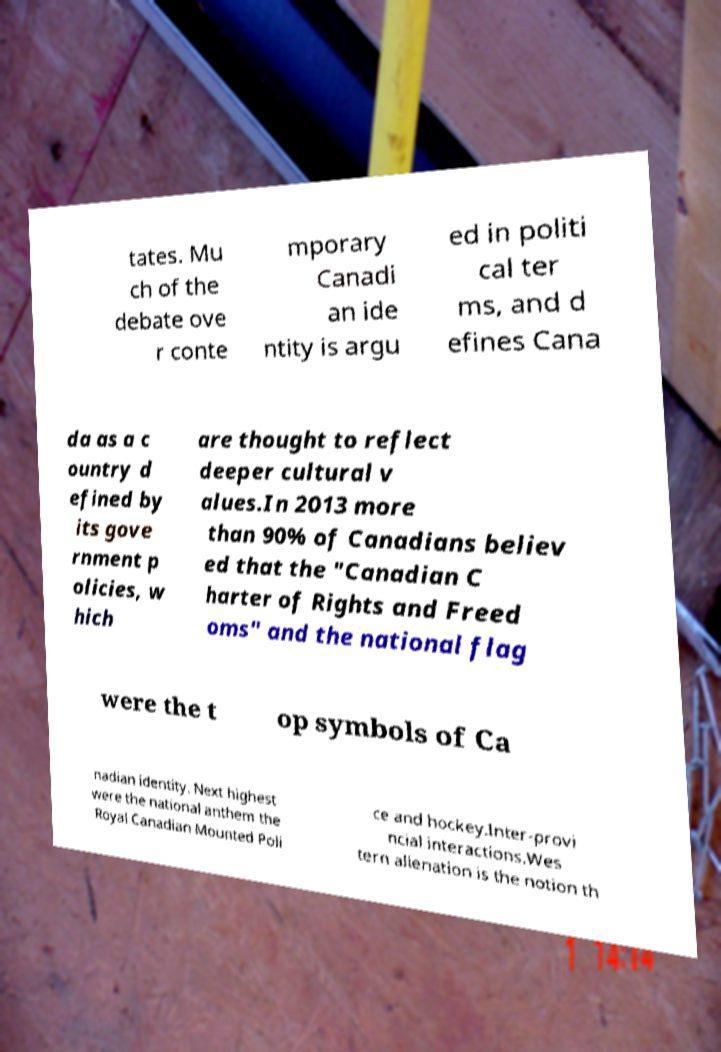For documentation purposes, I need the text within this image transcribed. Could you provide that? tates. Mu ch of the debate ove r conte mporary Canadi an ide ntity is argu ed in politi cal ter ms, and d efines Cana da as a c ountry d efined by its gove rnment p olicies, w hich are thought to reflect deeper cultural v alues.In 2013 more than 90% of Canadians believ ed that the "Canadian C harter of Rights and Freed oms" and the national flag were the t op symbols of Ca nadian identity. Next highest were the national anthem the Royal Canadian Mounted Poli ce and hockey.Inter-provi ncial interactions.Wes tern alienation is the notion th 